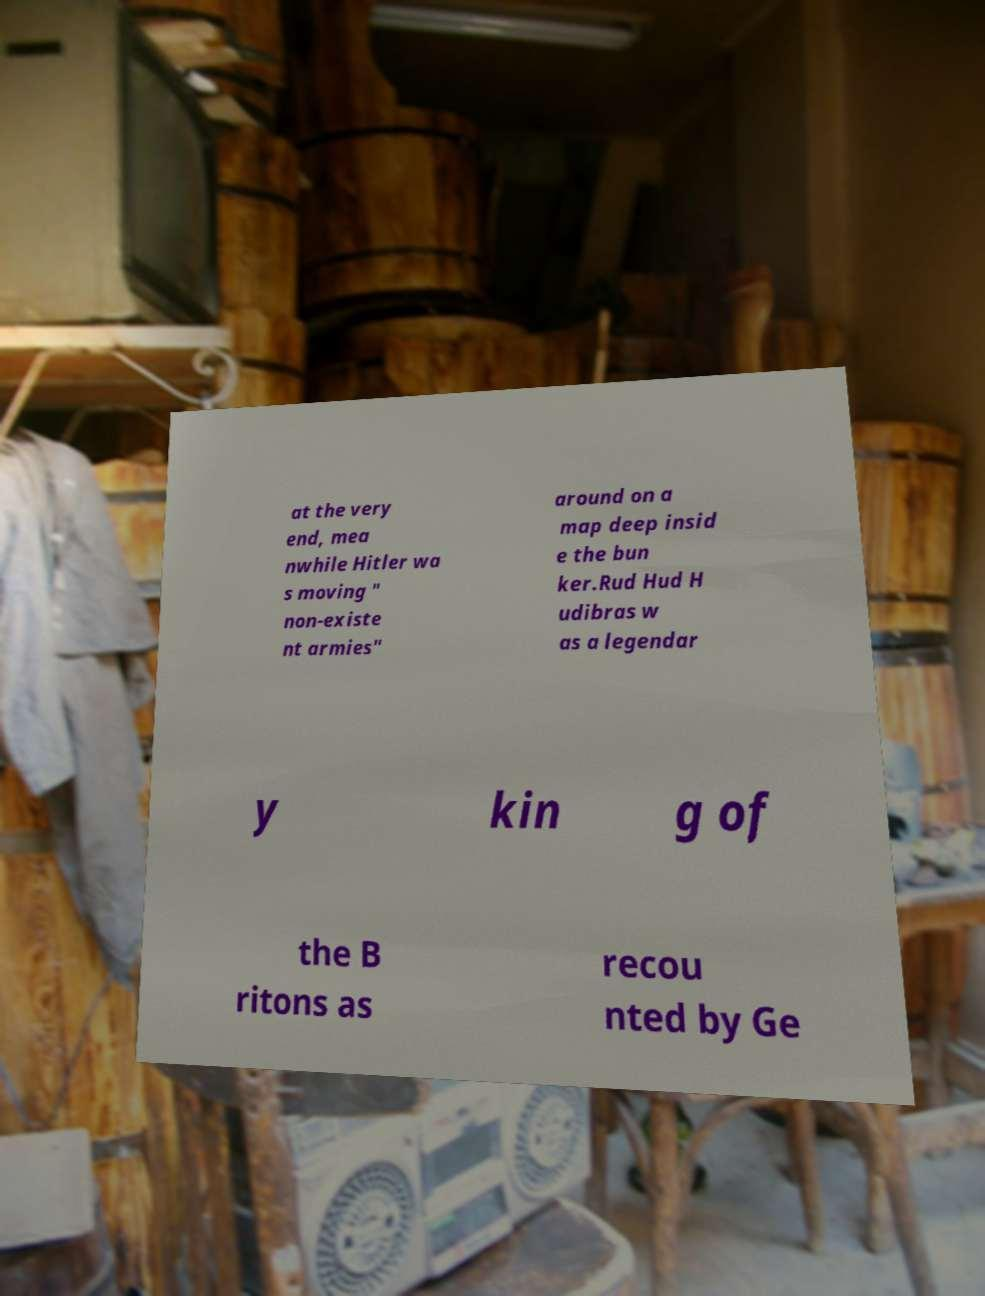What messages or text are displayed in this image? I need them in a readable, typed format. at the very end, mea nwhile Hitler wa s moving " non-existe nt armies" around on a map deep insid e the bun ker.Rud Hud H udibras w as a legendar y kin g of the B ritons as recou nted by Ge 